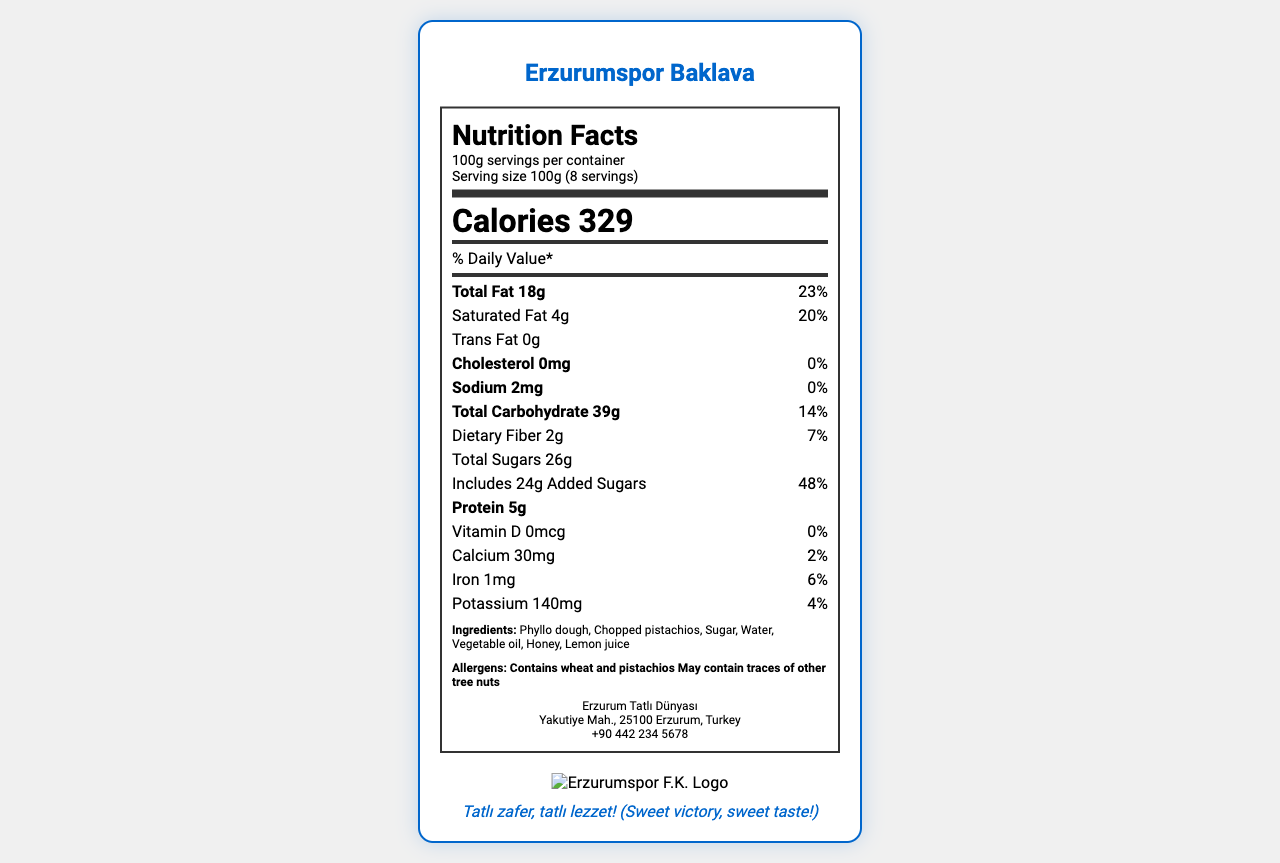who is the manufacturer of Erzurumspor Baklava? The manufacturer's information is listed under the "manufacturer" section of the document, specifying the name Erzurum Tatlı Dünyası.
Answer: Erzurum Tatlı Dünyası what is the serving size of Erzurumspor Baklava? The serving size is mentioned in the "serving-info" section of the document.
Answer: 100g how much calcium is in one serving of Erzurumspor Baklava? The amount of calcium per serving is specified in the "nutrient" section that lists vitamins and minerals.
Answer: 30mg what allergens are present in Erzurumspor Baklava? The allergens are listed in the "allergens" section.
Answer: Contains wheat and pistachios, May contain traces of other tree nuts what are the key colors used in the packaging design of the baklava? The primary color is "#0066CC" (blue) and the secondary color is "#FFFFFF" (white), as specified in the "packageDesign" section.
Answer: Blue and White how many calories are in one serving of Erzurumspor Baklava? The calorie count per serving is prominently displayed in the "calories" section.
Answer: 329 calories what percentage of daily value is the total fat in one serving? A. 20% B. 23% C. 25% D. 30% The total fat daily value is listed as 23% in the "nutrient" section.
Answer: B. 23% which of the following is NOT an ingredient of Erzurumspor Baklava? 1. Phyllo dough 2. Honey 3. Almonds 4. Lemon juice Almonds are not listed in the "ingredients" section of the document.
Answer: 3. Almonds is the baklava considered high in added sugars? The daily value of added sugars is 48%, which is high, as indicated in the "nutrient" section for added sugars.
Answer: Yes does Erzurumspor Baklava contain any artificial preservatives? The document highlights "no artificial preservatives" under the "nutritionalHighlights" section.
Answer: No how many servings are in one container of Erzurumspor Baklava? The number of servings per container is mentioned in the "serving-info" section.
Answer: 8 servings why is the Erzurumspor Baklava packaging collectible? The "specialFeatures" section mentions that it is a limited edition commemorative box for the 2023 Süper Lig Season and includes an official verification hologram.
Answer: It is a limited edition 2023 Süper Lig Season Commemorative Box with an authenticity hologram. what are the storage instructions for the baklava? The "storageInstructions" section provides details on how the baklava should be stored.
Answer: Store in a cool, dry place. Best consumed within 2 weeks of opening. describe the main idea of the document. The document outlines various details about Erzurumspor Baklava, including serving size, nutrients, storage instructions, and special packaging features, making it clear and informative for consumers.
Answer: The document is a detailed nutrition facts label for Erzurumspor Baklava, listing its ingredients, nutritional information, manufacturer details, and special features like collectible packaging. what type of matchday snack is Erzurumspor Baklava promoted as? The document notes under "nutritionalHighlights" that the baklava is a "Perfect snack for match days" due to its energy content.
Answer: A source of energy what is the contact number of the manufacturer? The manufacturer's contact number is provided in the "manufacturer" section.
Answer: +90 442 234 5678 where should the Erzurumspor Baklava be stored? The document doesn't specify where exactly to store the baklava, only that it should be in a cool, dry place.
Answer: Not enough information how much protein is in one serving of Erzurumspor Baklava? The amount of protein per serving is listed in the "nutrient" section.
Answer: 5g 